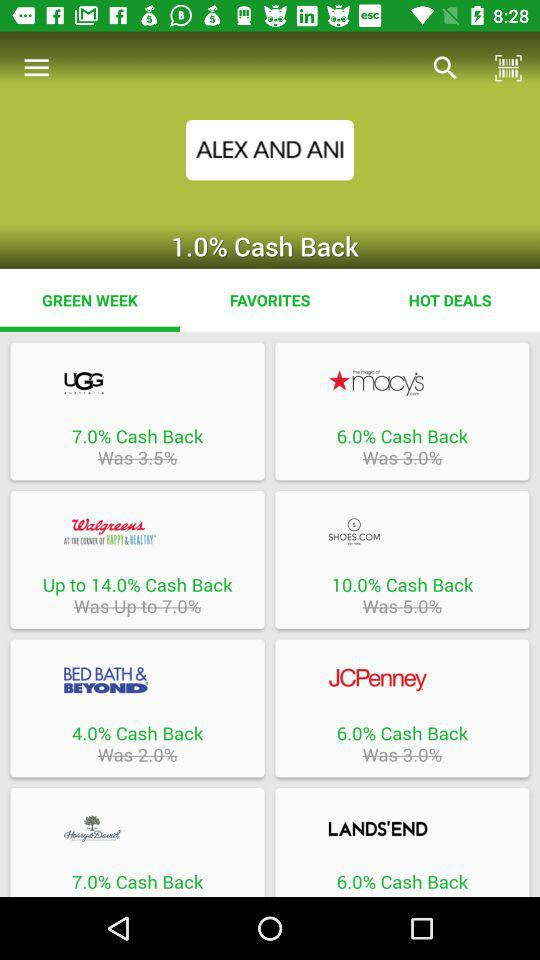How many percent cash back is offered on LANDS'END?
Answer the question using a single word or phrase. 6.0% 